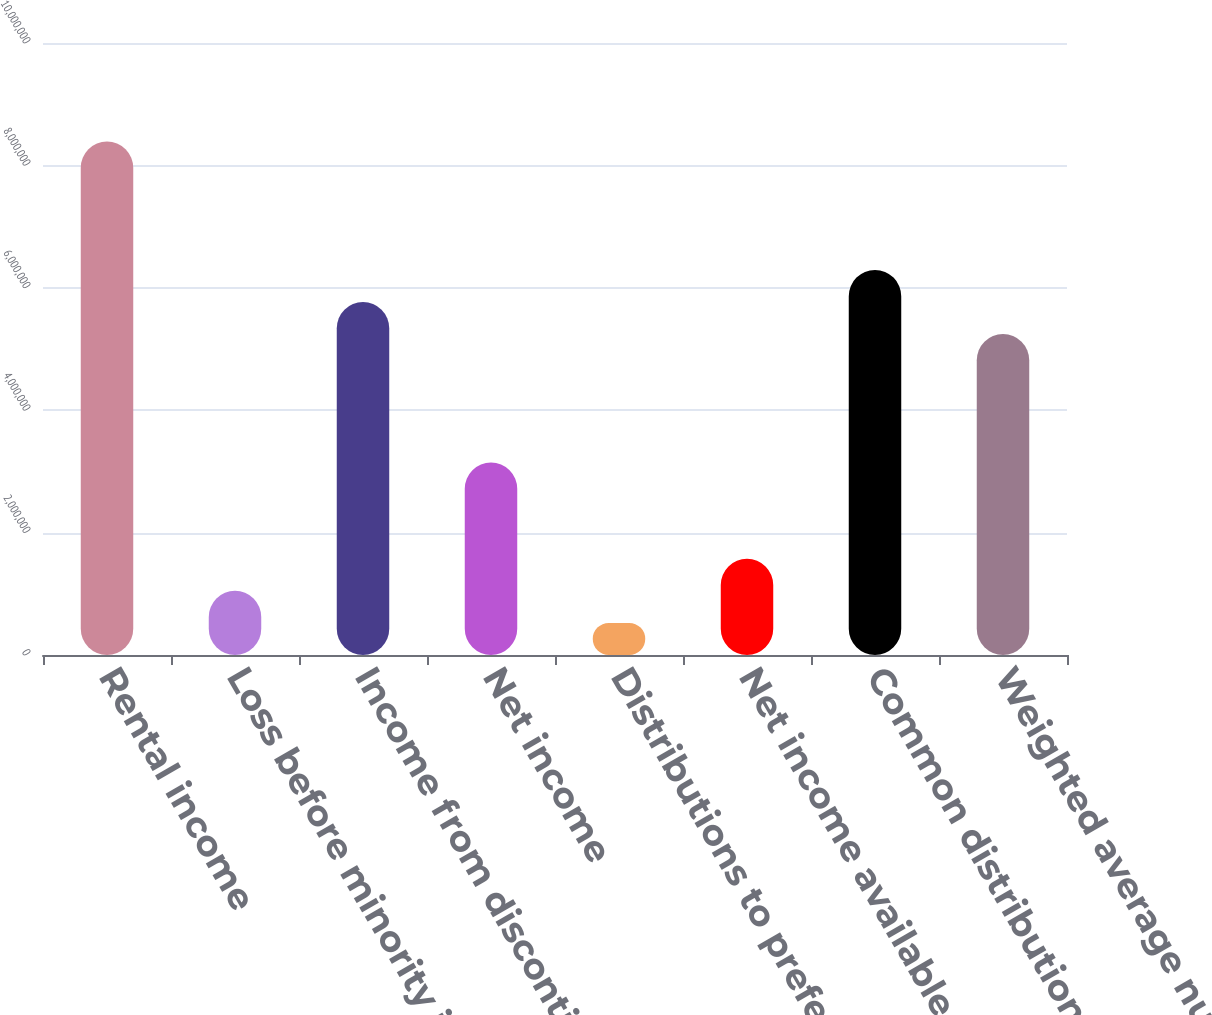Convert chart to OTSL. <chart><loc_0><loc_0><loc_500><loc_500><bar_chart><fcel>Rental income<fcel>Loss before minority interests<fcel>Income from discontinued<fcel>Net income<fcel>Distributions to preferred<fcel>Net income available to common<fcel>Common distributions declared<fcel>Weighted average number of<nl><fcel>8.38927e+06<fcel>1.04866e+06<fcel>5.76763e+06<fcel>3.14598e+06<fcel>524330<fcel>1.57299e+06<fcel>6.29196e+06<fcel>5.2433e+06<nl></chart> 